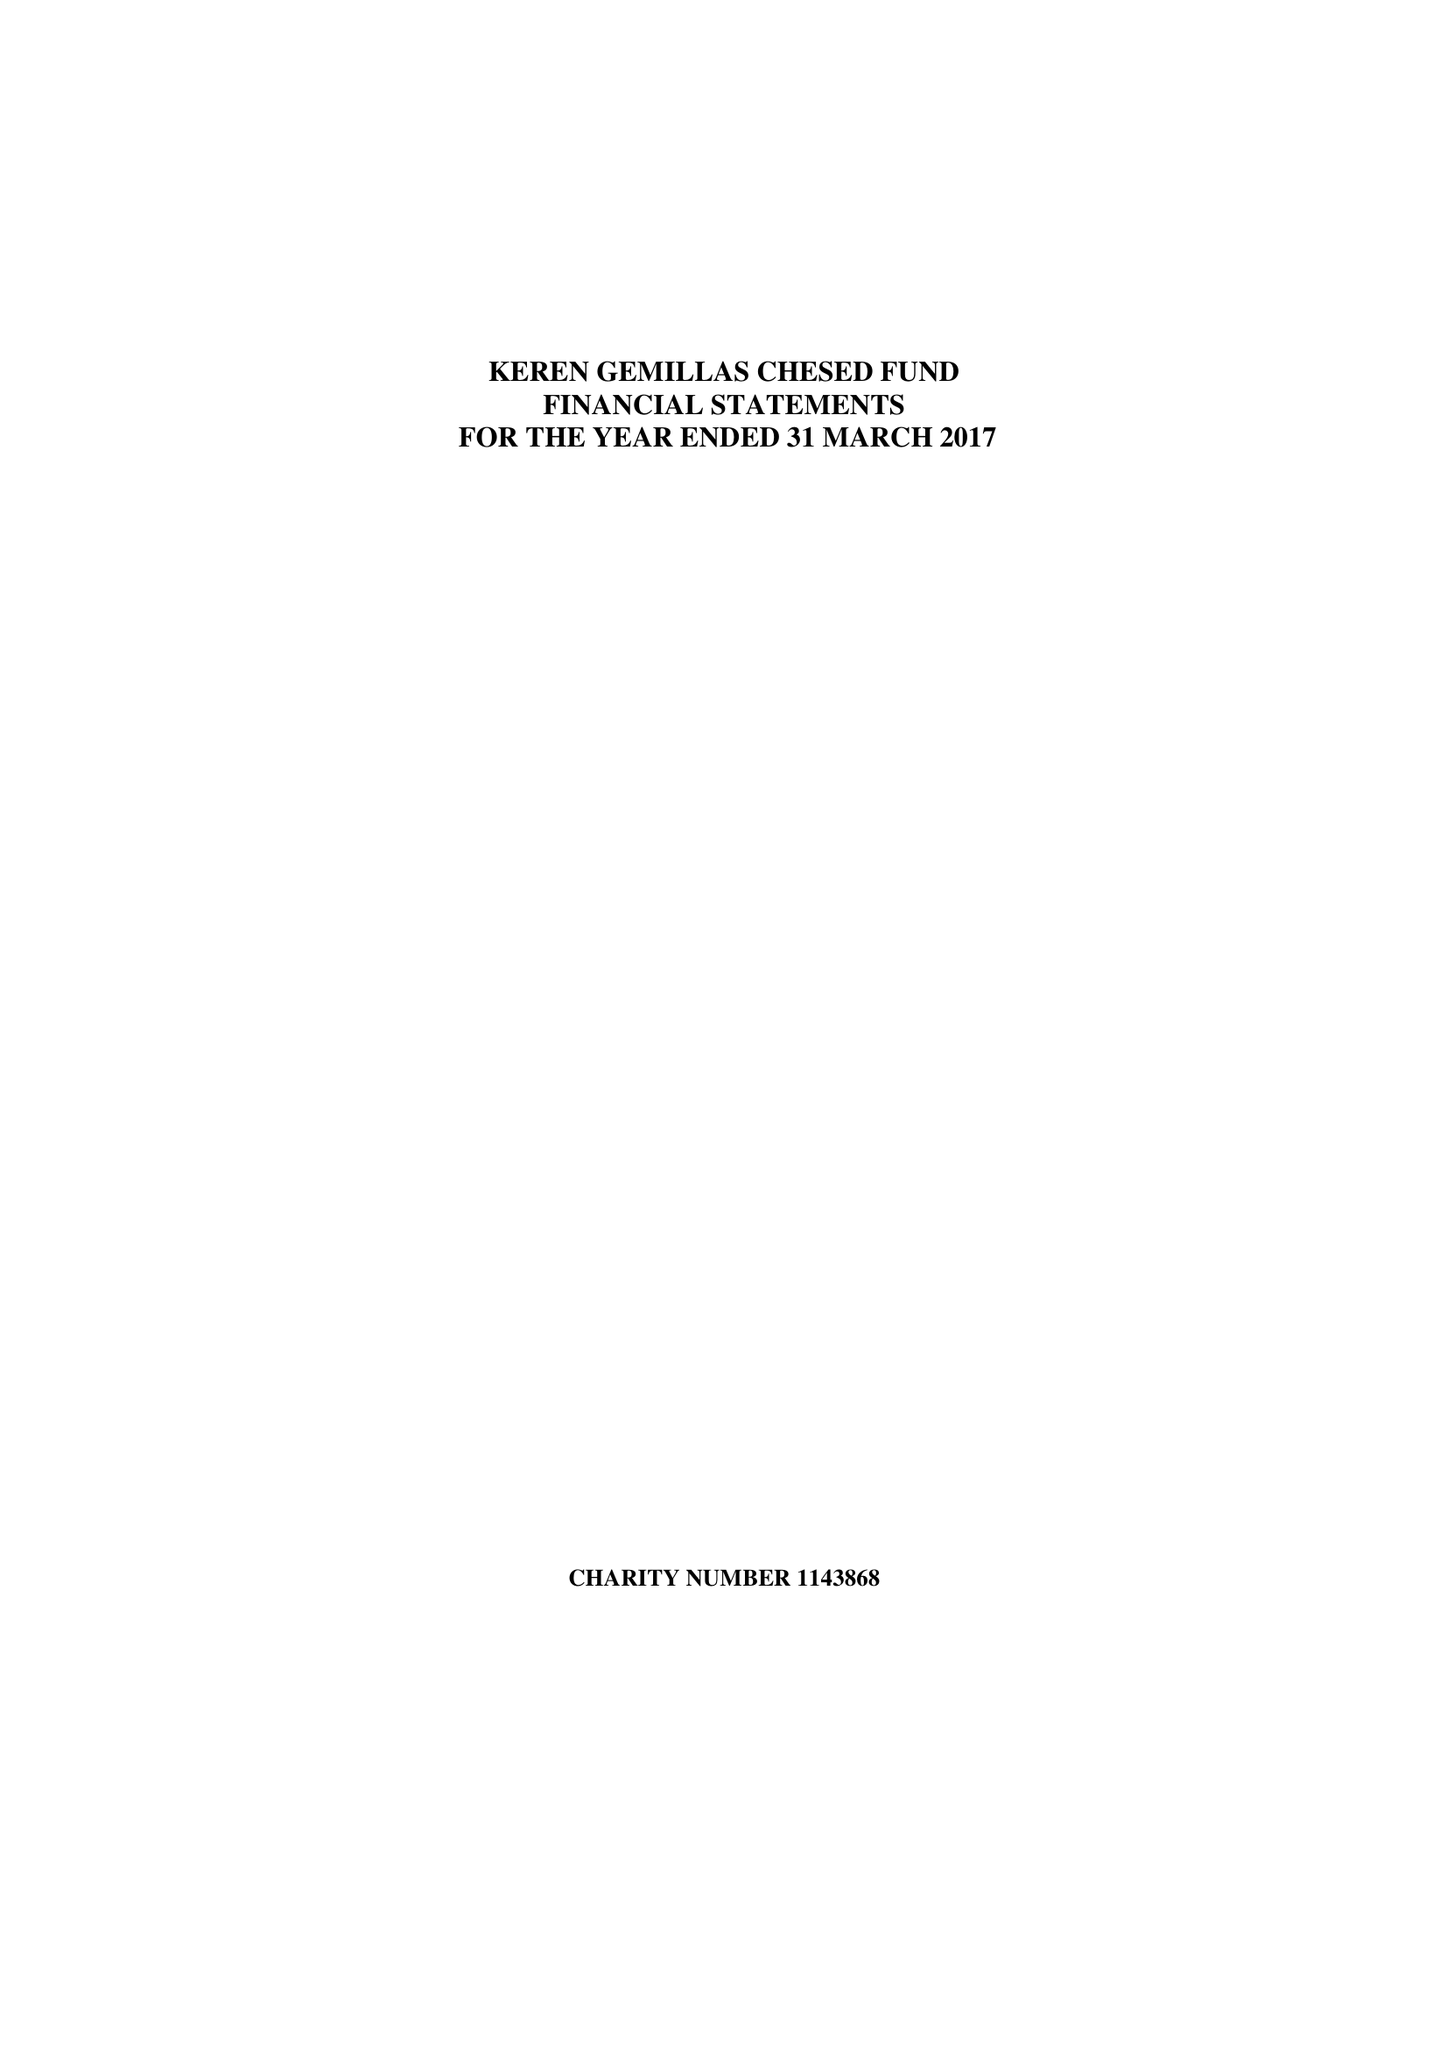What is the value for the charity_name?
Answer the question using a single word or phrase. Keren Gemillas Chesed Fund 